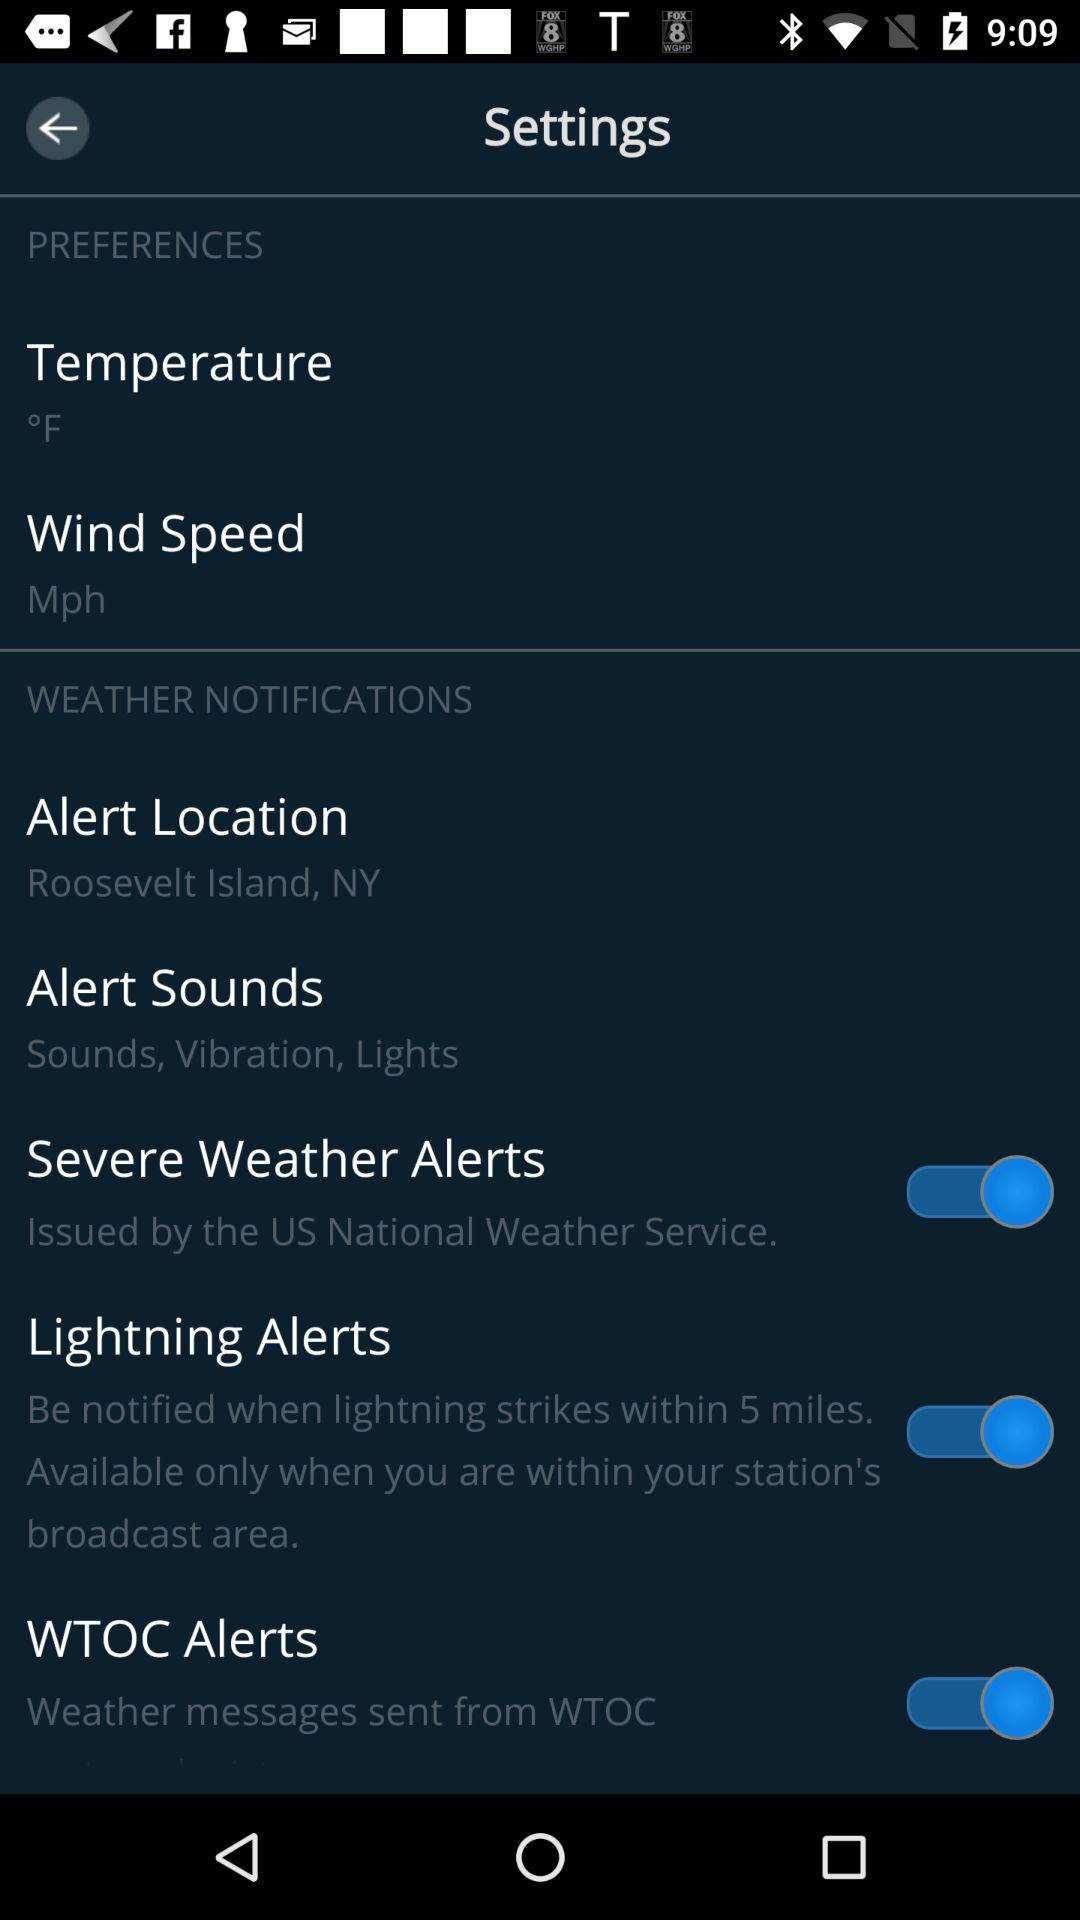What are the "Alert Sounds"? The alert sounds are "Sounds, Vibration, Lights". 